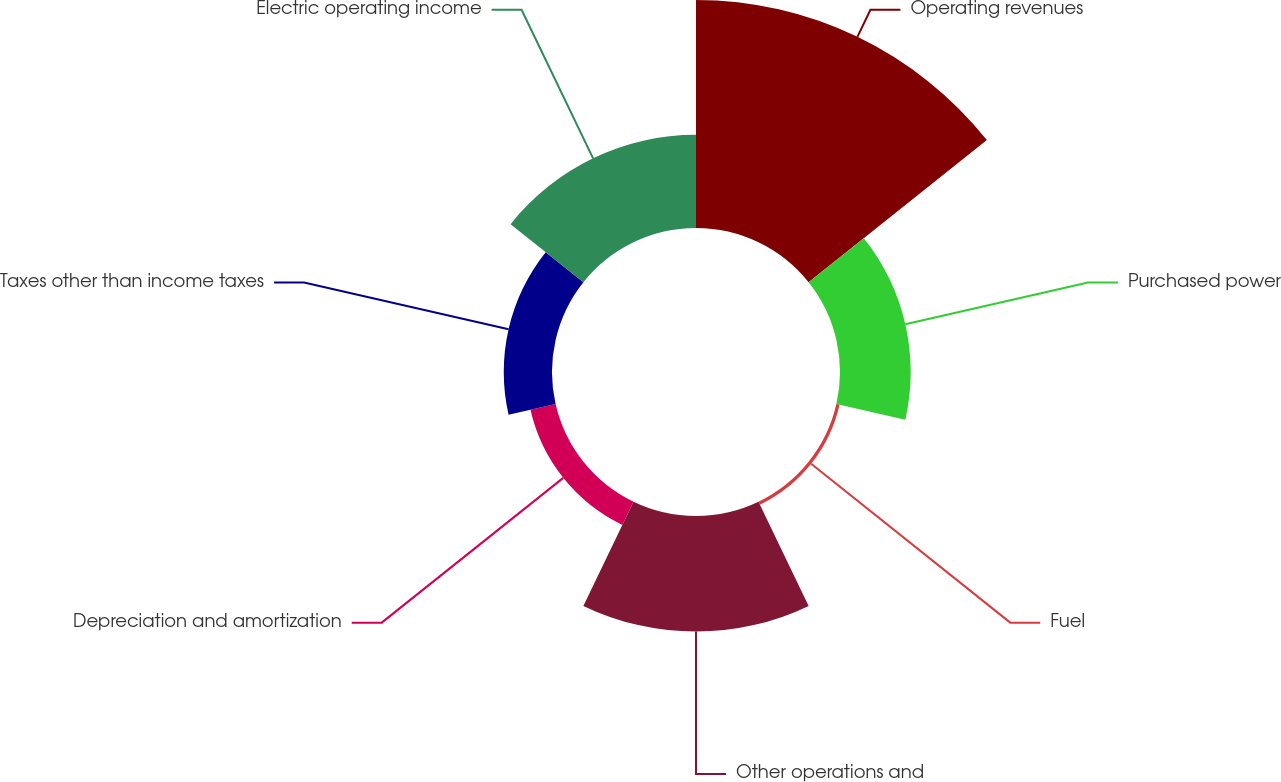<chart> <loc_0><loc_0><loc_500><loc_500><pie_chart><fcel>Operating revenues<fcel>Purchased power<fcel>Fuel<fcel>Other operations and<fcel>Depreciation and amortization<fcel>Taxes other than income taxes<fcel>Electric operating income<nl><fcel>38.99%<fcel>12.09%<fcel>0.56%<fcel>19.77%<fcel>4.41%<fcel>8.25%<fcel>15.93%<nl></chart> 